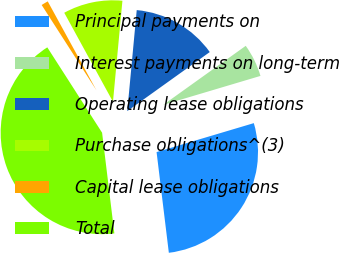<chart> <loc_0><loc_0><loc_500><loc_500><pie_chart><fcel>Principal payments on<fcel>Interest payments on long-term<fcel>Operating lease obligations<fcel>Purchase obligations^(3)<fcel>Capital lease obligations<fcel>Total<nl><fcel>27.68%<fcel>5.28%<fcel>13.63%<fcel>9.46%<fcel>1.11%<fcel>42.85%<nl></chart> 